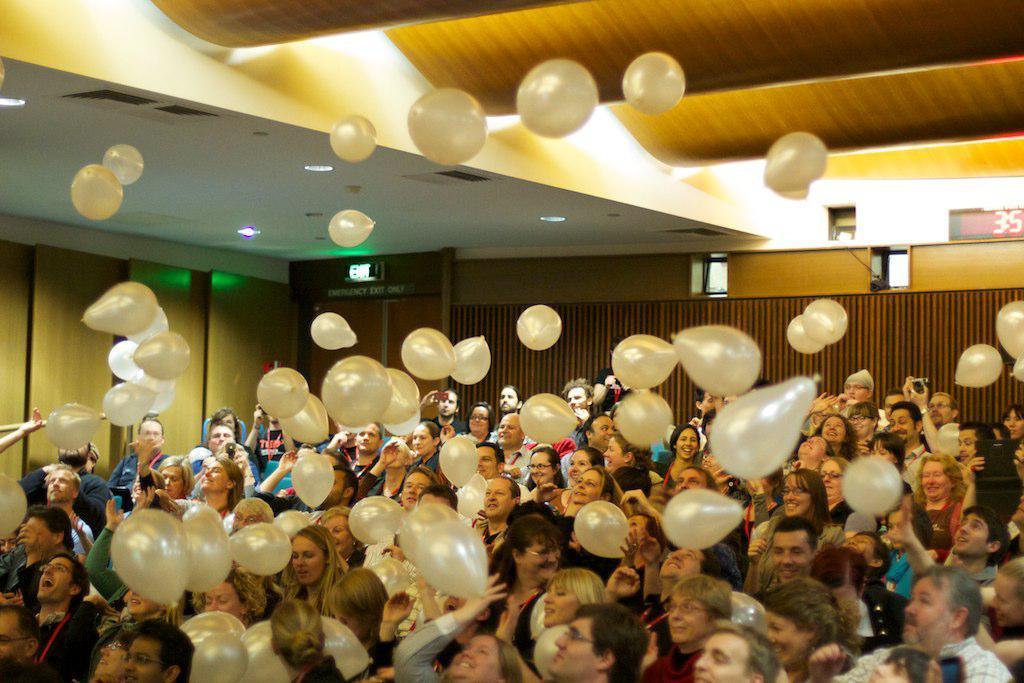How would you summarize this image in a sentence or two? In this image we can see a few people, there are balloons, there are lights, ceiling, also we can see the wall, and board with some text on it. 